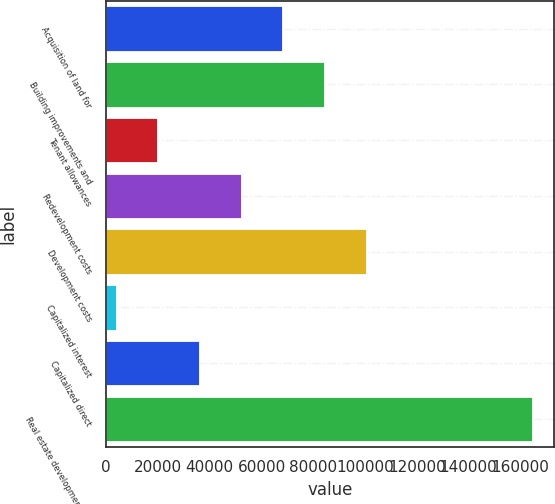Convert chart. <chart><loc_0><loc_0><loc_500><loc_500><bar_chart><fcel>Acquisition of land for<fcel>Building improvements and<fcel>Tenant allowances<fcel>Redevelopment costs<fcel>Development costs<fcel>Capitalized interest<fcel>Capitalized direct<fcel>Real estate development and<nl><fcel>68046.8<fcel>84137<fcel>19776.2<fcel>51956.6<fcel>100227<fcel>3686<fcel>35866.4<fcel>164588<nl></chart> 